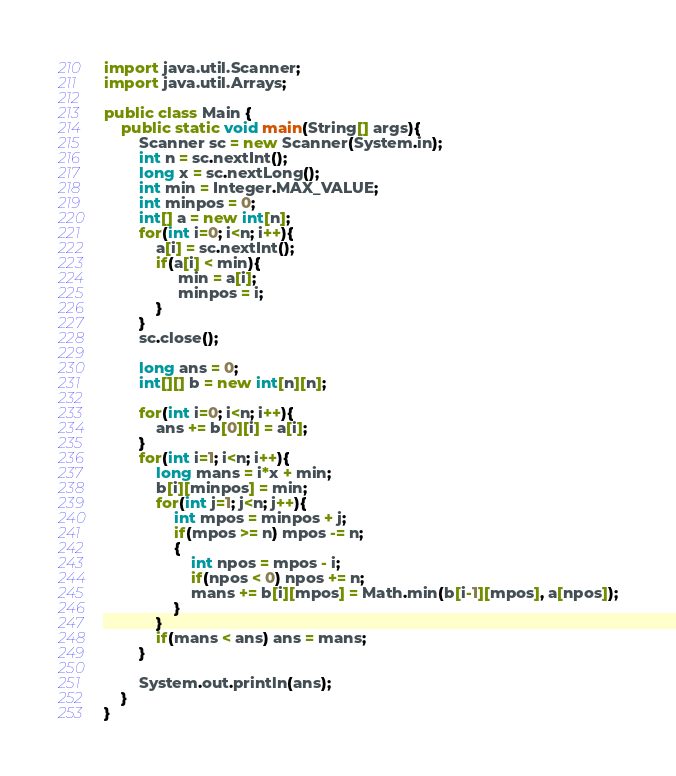Convert code to text. <code><loc_0><loc_0><loc_500><loc_500><_Java_>import java.util.Scanner;
import java.util.Arrays;

public class Main {
	public static void main(String[] args){
		Scanner sc = new Scanner(System.in);
        int n = sc.nextInt();
        long x = sc.nextLong();
        int min = Integer.MAX_VALUE;
        int minpos = 0;
        int[] a = new int[n];
        for(int i=0; i<n; i++){
            a[i] = sc.nextInt();
            if(a[i] < min){
                 min = a[i];
                 minpos = i;
            }
        }
        sc.close();

        long ans = 0;
        int[][] b = new int[n][n];
        
        for(int i=0; i<n; i++){
            ans += b[0][i] = a[i];
        }
        for(int i=1; i<n; i++){
            long mans = i*x + min;
            b[i][minpos] = min;
            for(int j=1; j<n; j++){
                int mpos = minpos + j;
                if(mpos >= n) mpos -= n;
                {
                    int npos = mpos - i;
                    if(npos < 0) npos += n;
                    mans += b[i][mpos] = Math.min(b[i-1][mpos], a[npos]);
                }
            }
            if(mans < ans) ans = mans;
        }

        System.out.println(ans);
	}
}
</code> 